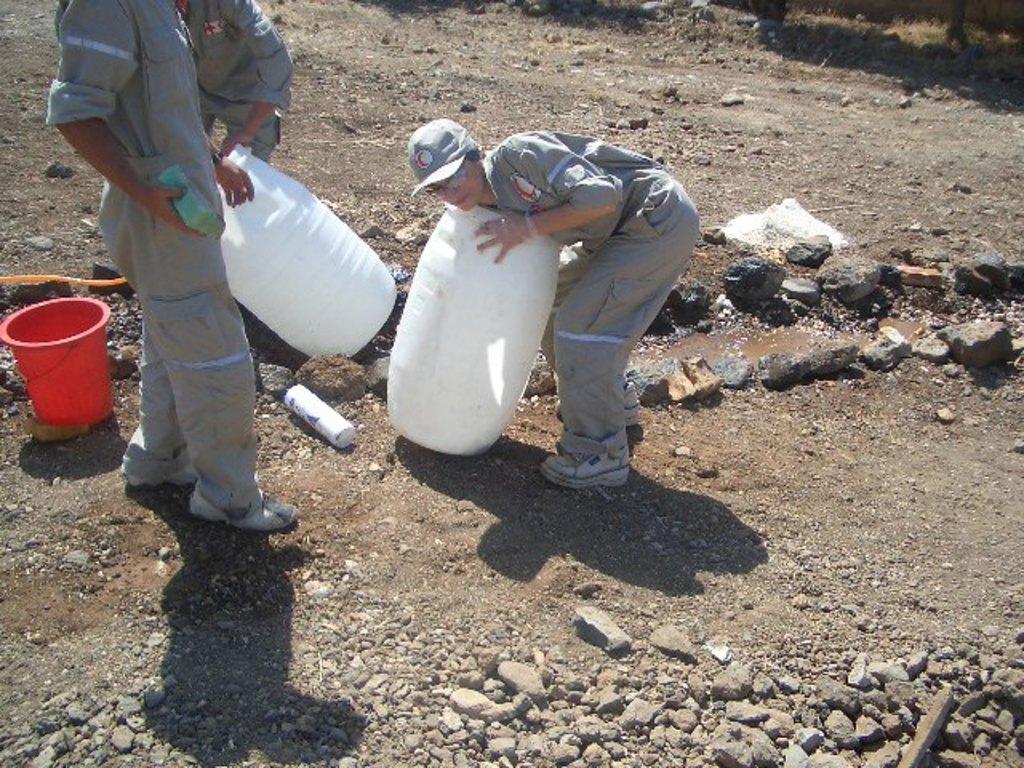How would you summarize this image in a sentence or two? In this image image we can see people and there are containers. At the bottom there are stones. On the left there is a bucket. We can see a person's hand holding a sponge. 